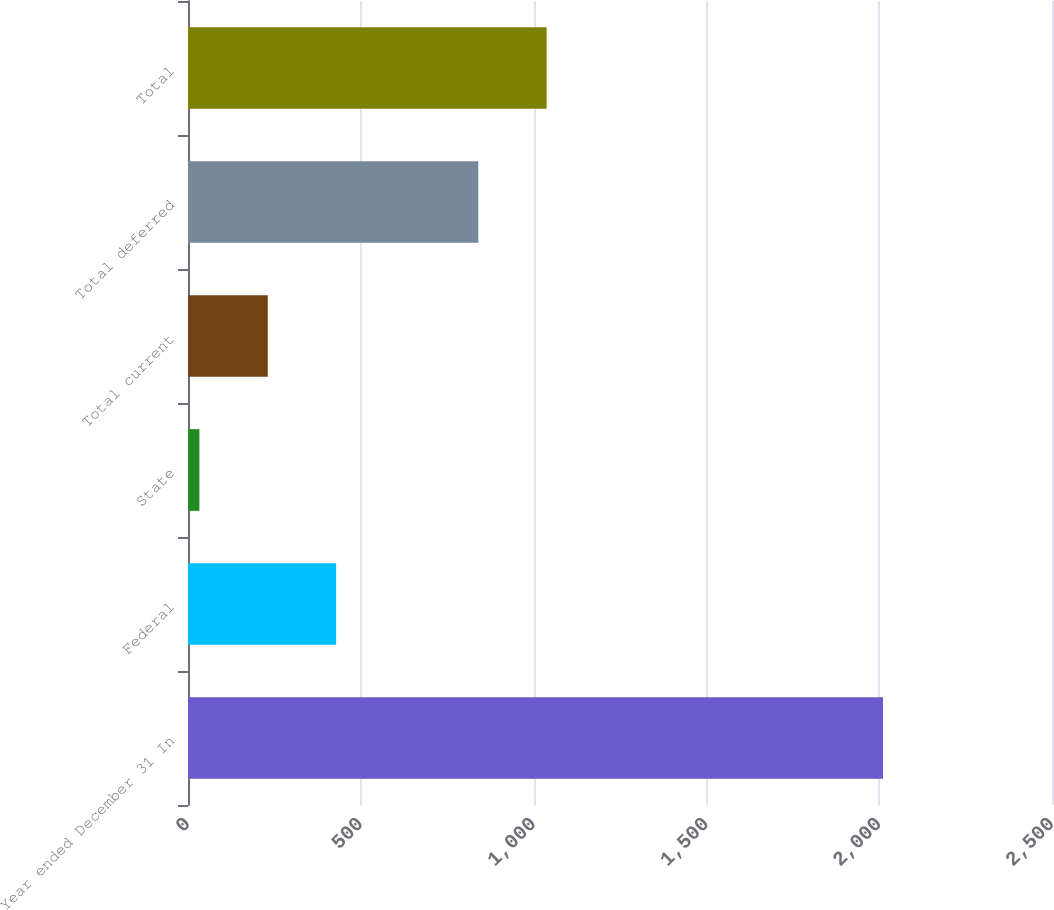<chart> <loc_0><loc_0><loc_500><loc_500><bar_chart><fcel>Year ended December 31 In<fcel>Federal<fcel>State<fcel>Total current<fcel>Total deferred<fcel>Total<nl><fcel>2011<fcel>428.6<fcel>33<fcel>230.8<fcel>840<fcel>1037.8<nl></chart> 